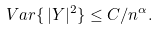<formula> <loc_0><loc_0><loc_500><loc_500>V a r \{ \, | Y | ^ { 2 } \} \leq C / n ^ { \alpha } .</formula> 